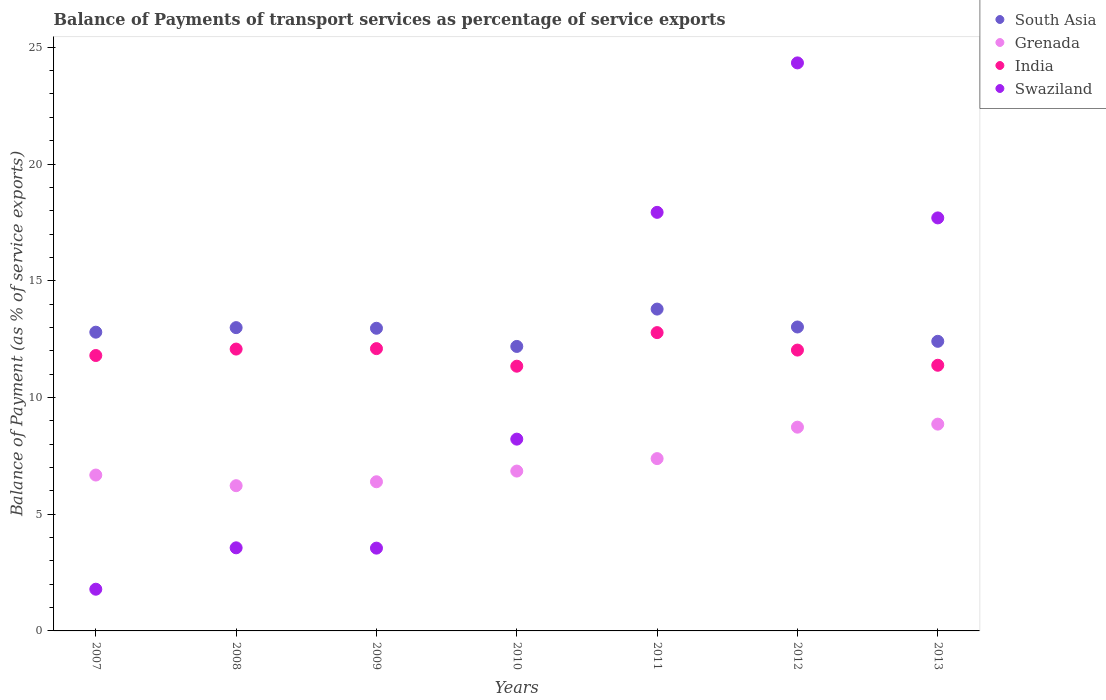What is the balance of payments of transport services in Swaziland in 2010?
Offer a very short reply. 8.22. Across all years, what is the maximum balance of payments of transport services in India?
Offer a terse response. 12.78. Across all years, what is the minimum balance of payments of transport services in India?
Offer a very short reply. 11.34. In which year was the balance of payments of transport services in India maximum?
Your answer should be compact. 2011. In which year was the balance of payments of transport services in India minimum?
Ensure brevity in your answer.  2010. What is the total balance of payments of transport services in South Asia in the graph?
Keep it short and to the point. 90.15. What is the difference between the balance of payments of transport services in India in 2007 and that in 2013?
Give a very brief answer. 0.42. What is the difference between the balance of payments of transport services in South Asia in 2009 and the balance of payments of transport services in Swaziland in 2010?
Provide a succinct answer. 4.75. What is the average balance of payments of transport services in Swaziland per year?
Keep it short and to the point. 11.01. In the year 2010, what is the difference between the balance of payments of transport services in Grenada and balance of payments of transport services in India?
Your response must be concise. -4.49. In how many years, is the balance of payments of transport services in Swaziland greater than 15 %?
Make the answer very short. 3. What is the ratio of the balance of payments of transport services in Grenada in 2008 to that in 2013?
Your answer should be very brief. 0.7. Is the balance of payments of transport services in Swaziland in 2009 less than that in 2010?
Provide a succinct answer. Yes. Is the difference between the balance of payments of transport services in Grenada in 2011 and 2013 greater than the difference between the balance of payments of transport services in India in 2011 and 2013?
Your response must be concise. No. What is the difference between the highest and the second highest balance of payments of transport services in Swaziland?
Offer a terse response. 6.4. What is the difference between the highest and the lowest balance of payments of transport services in India?
Offer a terse response. 1.44. In how many years, is the balance of payments of transport services in India greater than the average balance of payments of transport services in India taken over all years?
Offer a terse response. 4. Is the sum of the balance of payments of transport services in Swaziland in 2009 and 2010 greater than the maximum balance of payments of transport services in India across all years?
Your response must be concise. No. Is it the case that in every year, the sum of the balance of payments of transport services in Grenada and balance of payments of transport services in South Asia  is greater than the balance of payments of transport services in Swaziland?
Offer a terse response. No. Does the balance of payments of transport services in Grenada monotonically increase over the years?
Offer a terse response. No. Is the balance of payments of transport services in Swaziland strictly greater than the balance of payments of transport services in Grenada over the years?
Offer a terse response. No. Is the balance of payments of transport services in Swaziland strictly less than the balance of payments of transport services in Grenada over the years?
Ensure brevity in your answer.  No. How many dotlines are there?
Ensure brevity in your answer.  4. Are the values on the major ticks of Y-axis written in scientific E-notation?
Keep it short and to the point. No. Does the graph contain grids?
Keep it short and to the point. No. What is the title of the graph?
Provide a succinct answer. Balance of Payments of transport services as percentage of service exports. Does "Euro area" appear as one of the legend labels in the graph?
Offer a very short reply. No. What is the label or title of the Y-axis?
Provide a succinct answer. Balance of Payment (as % of service exports). What is the Balance of Payment (as % of service exports) of South Asia in 2007?
Provide a short and direct response. 12.8. What is the Balance of Payment (as % of service exports) in Grenada in 2007?
Keep it short and to the point. 6.68. What is the Balance of Payment (as % of service exports) of India in 2007?
Offer a very short reply. 11.8. What is the Balance of Payment (as % of service exports) of Swaziland in 2007?
Your response must be concise. 1.79. What is the Balance of Payment (as % of service exports) of South Asia in 2008?
Make the answer very short. 12.99. What is the Balance of Payment (as % of service exports) in Grenada in 2008?
Your answer should be compact. 6.22. What is the Balance of Payment (as % of service exports) of India in 2008?
Your answer should be very brief. 12.07. What is the Balance of Payment (as % of service exports) in Swaziland in 2008?
Your response must be concise. 3.56. What is the Balance of Payment (as % of service exports) in South Asia in 2009?
Offer a terse response. 12.96. What is the Balance of Payment (as % of service exports) in Grenada in 2009?
Your response must be concise. 6.39. What is the Balance of Payment (as % of service exports) in India in 2009?
Make the answer very short. 12.09. What is the Balance of Payment (as % of service exports) of Swaziland in 2009?
Your response must be concise. 3.55. What is the Balance of Payment (as % of service exports) in South Asia in 2010?
Make the answer very short. 12.19. What is the Balance of Payment (as % of service exports) in Grenada in 2010?
Your response must be concise. 6.85. What is the Balance of Payment (as % of service exports) in India in 2010?
Keep it short and to the point. 11.34. What is the Balance of Payment (as % of service exports) of Swaziland in 2010?
Provide a succinct answer. 8.22. What is the Balance of Payment (as % of service exports) of South Asia in 2011?
Keep it short and to the point. 13.79. What is the Balance of Payment (as % of service exports) of Grenada in 2011?
Give a very brief answer. 7.38. What is the Balance of Payment (as % of service exports) of India in 2011?
Provide a short and direct response. 12.78. What is the Balance of Payment (as % of service exports) of Swaziland in 2011?
Give a very brief answer. 17.93. What is the Balance of Payment (as % of service exports) of South Asia in 2012?
Keep it short and to the point. 13.02. What is the Balance of Payment (as % of service exports) in Grenada in 2012?
Make the answer very short. 8.73. What is the Balance of Payment (as % of service exports) of India in 2012?
Keep it short and to the point. 12.03. What is the Balance of Payment (as % of service exports) of Swaziland in 2012?
Keep it short and to the point. 24.33. What is the Balance of Payment (as % of service exports) in South Asia in 2013?
Offer a terse response. 12.41. What is the Balance of Payment (as % of service exports) of Grenada in 2013?
Provide a succinct answer. 8.86. What is the Balance of Payment (as % of service exports) in India in 2013?
Make the answer very short. 11.38. What is the Balance of Payment (as % of service exports) of Swaziland in 2013?
Make the answer very short. 17.69. Across all years, what is the maximum Balance of Payment (as % of service exports) in South Asia?
Provide a succinct answer. 13.79. Across all years, what is the maximum Balance of Payment (as % of service exports) of Grenada?
Your response must be concise. 8.86. Across all years, what is the maximum Balance of Payment (as % of service exports) of India?
Your answer should be very brief. 12.78. Across all years, what is the maximum Balance of Payment (as % of service exports) in Swaziland?
Ensure brevity in your answer.  24.33. Across all years, what is the minimum Balance of Payment (as % of service exports) in South Asia?
Give a very brief answer. 12.19. Across all years, what is the minimum Balance of Payment (as % of service exports) in Grenada?
Your response must be concise. 6.22. Across all years, what is the minimum Balance of Payment (as % of service exports) in India?
Keep it short and to the point. 11.34. Across all years, what is the minimum Balance of Payment (as % of service exports) in Swaziland?
Your answer should be compact. 1.79. What is the total Balance of Payment (as % of service exports) in South Asia in the graph?
Make the answer very short. 90.15. What is the total Balance of Payment (as % of service exports) in Grenada in the graph?
Your answer should be compact. 51.1. What is the total Balance of Payment (as % of service exports) in India in the graph?
Make the answer very short. 83.49. What is the total Balance of Payment (as % of service exports) in Swaziland in the graph?
Keep it short and to the point. 77.06. What is the difference between the Balance of Payment (as % of service exports) of South Asia in 2007 and that in 2008?
Offer a very short reply. -0.19. What is the difference between the Balance of Payment (as % of service exports) of Grenada in 2007 and that in 2008?
Your response must be concise. 0.46. What is the difference between the Balance of Payment (as % of service exports) of India in 2007 and that in 2008?
Ensure brevity in your answer.  -0.28. What is the difference between the Balance of Payment (as % of service exports) of Swaziland in 2007 and that in 2008?
Your answer should be compact. -1.77. What is the difference between the Balance of Payment (as % of service exports) in South Asia in 2007 and that in 2009?
Offer a terse response. -0.17. What is the difference between the Balance of Payment (as % of service exports) of Grenada in 2007 and that in 2009?
Provide a succinct answer. 0.29. What is the difference between the Balance of Payment (as % of service exports) in India in 2007 and that in 2009?
Keep it short and to the point. -0.3. What is the difference between the Balance of Payment (as % of service exports) of Swaziland in 2007 and that in 2009?
Your response must be concise. -1.76. What is the difference between the Balance of Payment (as % of service exports) of South Asia in 2007 and that in 2010?
Give a very brief answer. 0.61. What is the difference between the Balance of Payment (as % of service exports) in Grenada in 2007 and that in 2010?
Provide a short and direct response. -0.17. What is the difference between the Balance of Payment (as % of service exports) in India in 2007 and that in 2010?
Ensure brevity in your answer.  0.46. What is the difference between the Balance of Payment (as % of service exports) in Swaziland in 2007 and that in 2010?
Give a very brief answer. -6.43. What is the difference between the Balance of Payment (as % of service exports) in South Asia in 2007 and that in 2011?
Offer a very short reply. -0.99. What is the difference between the Balance of Payment (as % of service exports) of Grenada in 2007 and that in 2011?
Give a very brief answer. -0.7. What is the difference between the Balance of Payment (as % of service exports) of India in 2007 and that in 2011?
Offer a terse response. -0.98. What is the difference between the Balance of Payment (as % of service exports) of Swaziland in 2007 and that in 2011?
Keep it short and to the point. -16.14. What is the difference between the Balance of Payment (as % of service exports) of South Asia in 2007 and that in 2012?
Offer a very short reply. -0.22. What is the difference between the Balance of Payment (as % of service exports) in Grenada in 2007 and that in 2012?
Your answer should be very brief. -2.05. What is the difference between the Balance of Payment (as % of service exports) in India in 2007 and that in 2012?
Provide a succinct answer. -0.23. What is the difference between the Balance of Payment (as % of service exports) in Swaziland in 2007 and that in 2012?
Keep it short and to the point. -22.55. What is the difference between the Balance of Payment (as % of service exports) in South Asia in 2007 and that in 2013?
Provide a succinct answer. 0.39. What is the difference between the Balance of Payment (as % of service exports) of Grenada in 2007 and that in 2013?
Provide a short and direct response. -2.18. What is the difference between the Balance of Payment (as % of service exports) of India in 2007 and that in 2013?
Offer a terse response. 0.42. What is the difference between the Balance of Payment (as % of service exports) of Swaziland in 2007 and that in 2013?
Give a very brief answer. -15.91. What is the difference between the Balance of Payment (as % of service exports) in South Asia in 2008 and that in 2009?
Keep it short and to the point. 0.03. What is the difference between the Balance of Payment (as % of service exports) of Grenada in 2008 and that in 2009?
Provide a short and direct response. -0.17. What is the difference between the Balance of Payment (as % of service exports) of India in 2008 and that in 2009?
Your answer should be compact. -0.02. What is the difference between the Balance of Payment (as % of service exports) in Swaziland in 2008 and that in 2009?
Your response must be concise. 0.01. What is the difference between the Balance of Payment (as % of service exports) in South Asia in 2008 and that in 2010?
Keep it short and to the point. 0.81. What is the difference between the Balance of Payment (as % of service exports) of Grenada in 2008 and that in 2010?
Your answer should be compact. -0.63. What is the difference between the Balance of Payment (as % of service exports) in India in 2008 and that in 2010?
Provide a short and direct response. 0.73. What is the difference between the Balance of Payment (as % of service exports) in Swaziland in 2008 and that in 2010?
Make the answer very short. -4.66. What is the difference between the Balance of Payment (as % of service exports) of South Asia in 2008 and that in 2011?
Offer a very short reply. -0.79. What is the difference between the Balance of Payment (as % of service exports) in Grenada in 2008 and that in 2011?
Your answer should be very brief. -1.16. What is the difference between the Balance of Payment (as % of service exports) in India in 2008 and that in 2011?
Keep it short and to the point. -0.7. What is the difference between the Balance of Payment (as % of service exports) in Swaziland in 2008 and that in 2011?
Your answer should be very brief. -14.37. What is the difference between the Balance of Payment (as % of service exports) of South Asia in 2008 and that in 2012?
Ensure brevity in your answer.  -0.03. What is the difference between the Balance of Payment (as % of service exports) of Grenada in 2008 and that in 2012?
Offer a very short reply. -2.51. What is the difference between the Balance of Payment (as % of service exports) in India in 2008 and that in 2012?
Offer a terse response. 0.04. What is the difference between the Balance of Payment (as % of service exports) of Swaziland in 2008 and that in 2012?
Give a very brief answer. -20.77. What is the difference between the Balance of Payment (as % of service exports) in South Asia in 2008 and that in 2013?
Give a very brief answer. 0.59. What is the difference between the Balance of Payment (as % of service exports) of Grenada in 2008 and that in 2013?
Ensure brevity in your answer.  -2.64. What is the difference between the Balance of Payment (as % of service exports) of India in 2008 and that in 2013?
Your answer should be very brief. 0.69. What is the difference between the Balance of Payment (as % of service exports) in Swaziland in 2008 and that in 2013?
Keep it short and to the point. -14.13. What is the difference between the Balance of Payment (as % of service exports) of South Asia in 2009 and that in 2010?
Your response must be concise. 0.78. What is the difference between the Balance of Payment (as % of service exports) of Grenada in 2009 and that in 2010?
Make the answer very short. -0.46. What is the difference between the Balance of Payment (as % of service exports) of India in 2009 and that in 2010?
Your answer should be compact. 0.75. What is the difference between the Balance of Payment (as % of service exports) of Swaziland in 2009 and that in 2010?
Offer a very short reply. -4.67. What is the difference between the Balance of Payment (as % of service exports) in South Asia in 2009 and that in 2011?
Offer a terse response. -0.82. What is the difference between the Balance of Payment (as % of service exports) of Grenada in 2009 and that in 2011?
Provide a succinct answer. -0.99. What is the difference between the Balance of Payment (as % of service exports) of India in 2009 and that in 2011?
Offer a very short reply. -0.69. What is the difference between the Balance of Payment (as % of service exports) in Swaziland in 2009 and that in 2011?
Your answer should be very brief. -14.38. What is the difference between the Balance of Payment (as % of service exports) of South Asia in 2009 and that in 2012?
Offer a terse response. -0.05. What is the difference between the Balance of Payment (as % of service exports) of Grenada in 2009 and that in 2012?
Give a very brief answer. -2.34. What is the difference between the Balance of Payment (as % of service exports) in India in 2009 and that in 2012?
Ensure brevity in your answer.  0.06. What is the difference between the Balance of Payment (as % of service exports) in Swaziland in 2009 and that in 2012?
Provide a succinct answer. -20.79. What is the difference between the Balance of Payment (as % of service exports) of South Asia in 2009 and that in 2013?
Give a very brief answer. 0.56. What is the difference between the Balance of Payment (as % of service exports) of Grenada in 2009 and that in 2013?
Provide a succinct answer. -2.47. What is the difference between the Balance of Payment (as % of service exports) of India in 2009 and that in 2013?
Provide a succinct answer. 0.71. What is the difference between the Balance of Payment (as % of service exports) in Swaziland in 2009 and that in 2013?
Your response must be concise. -14.15. What is the difference between the Balance of Payment (as % of service exports) in South Asia in 2010 and that in 2011?
Offer a very short reply. -1.6. What is the difference between the Balance of Payment (as % of service exports) in Grenada in 2010 and that in 2011?
Offer a terse response. -0.53. What is the difference between the Balance of Payment (as % of service exports) of India in 2010 and that in 2011?
Ensure brevity in your answer.  -1.44. What is the difference between the Balance of Payment (as % of service exports) of Swaziland in 2010 and that in 2011?
Provide a short and direct response. -9.71. What is the difference between the Balance of Payment (as % of service exports) in South Asia in 2010 and that in 2012?
Your answer should be compact. -0.83. What is the difference between the Balance of Payment (as % of service exports) of Grenada in 2010 and that in 2012?
Ensure brevity in your answer.  -1.88. What is the difference between the Balance of Payment (as % of service exports) of India in 2010 and that in 2012?
Provide a short and direct response. -0.69. What is the difference between the Balance of Payment (as % of service exports) of Swaziland in 2010 and that in 2012?
Make the answer very short. -16.12. What is the difference between the Balance of Payment (as % of service exports) in South Asia in 2010 and that in 2013?
Your answer should be compact. -0.22. What is the difference between the Balance of Payment (as % of service exports) in Grenada in 2010 and that in 2013?
Keep it short and to the point. -2.01. What is the difference between the Balance of Payment (as % of service exports) of India in 2010 and that in 2013?
Provide a short and direct response. -0.04. What is the difference between the Balance of Payment (as % of service exports) in Swaziland in 2010 and that in 2013?
Your answer should be compact. -9.48. What is the difference between the Balance of Payment (as % of service exports) of South Asia in 2011 and that in 2012?
Ensure brevity in your answer.  0.77. What is the difference between the Balance of Payment (as % of service exports) in Grenada in 2011 and that in 2012?
Offer a very short reply. -1.35. What is the difference between the Balance of Payment (as % of service exports) in India in 2011 and that in 2012?
Make the answer very short. 0.75. What is the difference between the Balance of Payment (as % of service exports) of Swaziland in 2011 and that in 2012?
Your answer should be very brief. -6.4. What is the difference between the Balance of Payment (as % of service exports) in South Asia in 2011 and that in 2013?
Offer a terse response. 1.38. What is the difference between the Balance of Payment (as % of service exports) of Grenada in 2011 and that in 2013?
Offer a terse response. -1.48. What is the difference between the Balance of Payment (as % of service exports) of India in 2011 and that in 2013?
Your response must be concise. 1.4. What is the difference between the Balance of Payment (as % of service exports) of Swaziland in 2011 and that in 2013?
Keep it short and to the point. 0.24. What is the difference between the Balance of Payment (as % of service exports) in South Asia in 2012 and that in 2013?
Give a very brief answer. 0.61. What is the difference between the Balance of Payment (as % of service exports) in Grenada in 2012 and that in 2013?
Your response must be concise. -0.13. What is the difference between the Balance of Payment (as % of service exports) of India in 2012 and that in 2013?
Ensure brevity in your answer.  0.65. What is the difference between the Balance of Payment (as % of service exports) of Swaziland in 2012 and that in 2013?
Make the answer very short. 6.64. What is the difference between the Balance of Payment (as % of service exports) in South Asia in 2007 and the Balance of Payment (as % of service exports) in Grenada in 2008?
Provide a short and direct response. 6.58. What is the difference between the Balance of Payment (as % of service exports) in South Asia in 2007 and the Balance of Payment (as % of service exports) in India in 2008?
Keep it short and to the point. 0.72. What is the difference between the Balance of Payment (as % of service exports) in South Asia in 2007 and the Balance of Payment (as % of service exports) in Swaziland in 2008?
Make the answer very short. 9.24. What is the difference between the Balance of Payment (as % of service exports) in Grenada in 2007 and the Balance of Payment (as % of service exports) in India in 2008?
Keep it short and to the point. -5.4. What is the difference between the Balance of Payment (as % of service exports) of Grenada in 2007 and the Balance of Payment (as % of service exports) of Swaziland in 2008?
Offer a very short reply. 3.12. What is the difference between the Balance of Payment (as % of service exports) of India in 2007 and the Balance of Payment (as % of service exports) of Swaziland in 2008?
Your answer should be compact. 8.24. What is the difference between the Balance of Payment (as % of service exports) of South Asia in 2007 and the Balance of Payment (as % of service exports) of Grenada in 2009?
Provide a succinct answer. 6.41. What is the difference between the Balance of Payment (as % of service exports) of South Asia in 2007 and the Balance of Payment (as % of service exports) of India in 2009?
Offer a terse response. 0.7. What is the difference between the Balance of Payment (as % of service exports) in South Asia in 2007 and the Balance of Payment (as % of service exports) in Swaziland in 2009?
Provide a succinct answer. 9.25. What is the difference between the Balance of Payment (as % of service exports) of Grenada in 2007 and the Balance of Payment (as % of service exports) of India in 2009?
Offer a very short reply. -5.42. What is the difference between the Balance of Payment (as % of service exports) in Grenada in 2007 and the Balance of Payment (as % of service exports) in Swaziland in 2009?
Offer a very short reply. 3.13. What is the difference between the Balance of Payment (as % of service exports) in India in 2007 and the Balance of Payment (as % of service exports) in Swaziland in 2009?
Provide a succinct answer. 8.25. What is the difference between the Balance of Payment (as % of service exports) in South Asia in 2007 and the Balance of Payment (as % of service exports) in Grenada in 2010?
Provide a short and direct response. 5.95. What is the difference between the Balance of Payment (as % of service exports) in South Asia in 2007 and the Balance of Payment (as % of service exports) in India in 2010?
Keep it short and to the point. 1.46. What is the difference between the Balance of Payment (as % of service exports) of South Asia in 2007 and the Balance of Payment (as % of service exports) of Swaziland in 2010?
Make the answer very short. 4.58. What is the difference between the Balance of Payment (as % of service exports) of Grenada in 2007 and the Balance of Payment (as % of service exports) of India in 2010?
Offer a very short reply. -4.66. What is the difference between the Balance of Payment (as % of service exports) in Grenada in 2007 and the Balance of Payment (as % of service exports) in Swaziland in 2010?
Provide a succinct answer. -1.54. What is the difference between the Balance of Payment (as % of service exports) of India in 2007 and the Balance of Payment (as % of service exports) of Swaziland in 2010?
Your answer should be compact. 3.58. What is the difference between the Balance of Payment (as % of service exports) in South Asia in 2007 and the Balance of Payment (as % of service exports) in Grenada in 2011?
Make the answer very short. 5.42. What is the difference between the Balance of Payment (as % of service exports) in South Asia in 2007 and the Balance of Payment (as % of service exports) in India in 2011?
Offer a terse response. 0.02. What is the difference between the Balance of Payment (as % of service exports) in South Asia in 2007 and the Balance of Payment (as % of service exports) in Swaziland in 2011?
Your answer should be very brief. -5.13. What is the difference between the Balance of Payment (as % of service exports) in Grenada in 2007 and the Balance of Payment (as % of service exports) in India in 2011?
Offer a terse response. -6.1. What is the difference between the Balance of Payment (as % of service exports) in Grenada in 2007 and the Balance of Payment (as % of service exports) in Swaziland in 2011?
Offer a terse response. -11.25. What is the difference between the Balance of Payment (as % of service exports) in India in 2007 and the Balance of Payment (as % of service exports) in Swaziland in 2011?
Your answer should be very brief. -6.13. What is the difference between the Balance of Payment (as % of service exports) in South Asia in 2007 and the Balance of Payment (as % of service exports) in Grenada in 2012?
Provide a short and direct response. 4.07. What is the difference between the Balance of Payment (as % of service exports) of South Asia in 2007 and the Balance of Payment (as % of service exports) of India in 2012?
Offer a terse response. 0.77. What is the difference between the Balance of Payment (as % of service exports) of South Asia in 2007 and the Balance of Payment (as % of service exports) of Swaziland in 2012?
Make the answer very short. -11.54. What is the difference between the Balance of Payment (as % of service exports) in Grenada in 2007 and the Balance of Payment (as % of service exports) in India in 2012?
Provide a succinct answer. -5.35. What is the difference between the Balance of Payment (as % of service exports) of Grenada in 2007 and the Balance of Payment (as % of service exports) of Swaziland in 2012?
Your response must be concise. -17.65. What is the difference between the Balance of Payment (as % of service exports) of India in 2007 and the Balance of Payment (as % of service exports) of Swaziland in 2012?
Give a very brief answer. -12.53. What is the difference between the Balance of Payment (as % of service exports) of South Asia in 2007 and the Balance of Payment (as % of service exports) of Grenada in 2013?
Your answer should be compact. 3.94. What is the difference between the Balance of Payment (as % of service exports) of South Asia in 2007 and the Balance of Payment (as % of service exports) of India in 2013?
Offer a terse response. 1.42. What is the difference between the Balance of Payment (as % of service exports) of South Asia in 2007 and the Balance of Payment (as % of service exports) of Swaziland in 2013?
Make the answer very short. -4.89. What is the difference between the Balance of Payment (as % of service exports) of Grenada in 2007 and the Balance of Payment (as % of service exports) of India in 2013?
Offer a terse response. -4.7. What is the difference between the Balance of Payment (as % of service exports) of Grenada in 2007 and the Balance of Payment (as % of service exports) of Swaziland in 2013?
Keep it short and to the point. -11.01. What is the difference between the Balance of Payment (as % of service exports) of India in 2007 and the Balance of Payment (as % of service exports) of Swaziland in 2013?
Offer a very short reply. -5.89. What is the difference between the Balance of Payment (as % of service exports) in South Asia in 2008 and the Balance of Payment (as % of service exports) in Grenada in 2009?
Make the answer very short. 6.6. What is the difference between the Balance of Payment (as % of service exports) in South Asia in 2008 and the Balance of Payment (as % of service exports) in India in 2009?
Your answer should be compact. 0.9. What is the difference between the Balance of Payment (as % of service exports) of South Asia in 2008 and the Balance of Payment (as % of service exports) of Swaziland in 2009?
Make the answer very short. 9.45. What is the difference between the Balance of Payment (as % of service exports) in Grenada in 2008 and the Balance of Payment (as % of service exports) in India in 2009?
Give a very brief answer. -5.87. What is the difference between the Balance of Payment (as % of service exports) in Grenada in 2008 and the Balance of Payment (as % of service exports) in Swaziland in 2009?
Offer a terse response. 2.67. What is the difference between the Balance of Payment (as % of service exports) of India in 2008 and the Balance of Payment (as % of service exports) of Swaziland in 2009?
Provide a short and direct response. 8.53. What is the difference between the Balance of Payment (as % of service exports) of South Asia in 2008 and the Balance of Payment (as % of service exports) of Grenada in 2010?
Your answer should be very brief. 6.14. What is the difference between the Balance of Payment (as % of service exports) in South Asia in 2008 and the Balance of Payment (as % of service exports) in India in 2010?
Offer a very short reply. 1.65. What is the difference between the Balance of Payment (as % of service exports) in South Asia in 2008 and the Balance of Payment (as % of service exports) in Swaziland in 2010?
Offer a very short reply. 4.78. What is the difference between the Balance of Payment (as % of service exports) in Grenada in 2008 and the Balance of Payment (as % of service exports) in India in 2010?
Ensure brevity in your answer.  -5.12. What is the difference between the Balance of Payment (as % of service exports) in Grenada in 2008 and the Balance of Payment (as % of service exports) in Swaziland in 2010?
Offer a very short reply. -1.99. What is the difference between the Balance of Payment (as % of service exports) in India in 2008 and the Balance of Payment (as % of service exports) in Swaziland in 2010?
Your answer should be compact. 3.86. What is the difference between the Balance of Payment (as % of service exports) in South Asia in 2008 and the Balance of Payment (as % of service exports) in Grenada in 2011?
Offer a very short reply. 5.61. What is the difference between the Balance of Payment (as % of service exports) of South Asia in 2008 and the Balance of Payment (as % of service exports) of India in 2011?
Give a very brief answer. 0.21. What is the difference between the Balance of Payment (as % of service exports) in South Asia in 2008 and the Balance of Payment (as % of service exports) in Swaziland in 2011?
Your response must be concise. -4.94. What is the difference between the Balance of Payment (as % of service exports) of Grenada in 2008 and the Balance of Payment (as % of service exports) of India in 2011?
Offer a very short reply. -6.56. What is the difference between the Balance of Payment (as % of service exports) of Grenada in 2008 and the Balance of Payment (as % of service exports) of Swaziland in 2011?
Offer a very short reply. -11.71. What is the difference between the Balance of Payment (as % of service exports) of India in 2008 and the Balance of Payment (as % of service exports) of Swaziland in 2011?
Keep it short and to the point. -5.86. What is the difference between the Balance of Payment (as % of service exports) of South Asia in 2008 and the Balance of Payment (as % of service exports) of Grenada in 2012?
Ensure brevity in your answer.  4.26. What is the difference between the Balance of Payment (as % of service exports) in South Asia in 2008 and the Balance of Payment (as % of service exports) in India in 2012?
Your response must be concise. 0.96. What is the difference between the Balance of Payment (as % of service exports) of South Asia in 2008 and the Balance of Payment (as % of service exports) of Swaziland in 2012?
Your answer should be very brief. -11.34. What is the difference between the Balance of Payment (as % of service exports) in Grenada in 2008 and the Balance of Payment (as % of service exports) in India in 2012?
Your response must be concise. -5.81. What is the difference between the Balance of Payment (as % of service exports) in Grenada in 2008 and the Balance of Payment (as % of service exports) in Swaziland in 2012?
Your answer should be very brief. -18.11. What is the difference between the Balance of Payment (as % of service exports) in India in 2008 and the Balance of Payment (as % of service exports) in Swaziland in 2012?
Offer a terse response. -12.26. What is the difference between the Balance of Payment (as % of service exports) in South Asia in 2008 and the Balance of Payment (as % of service exports) in Grenada in 2013?
Offer a very short reply. 4.13. What is the difference between the Balance of Payment (as % of service exports) of South Asia in 2008 and the Balance of Payment (as % of service exports) of India in 2013?
Your answer should be very brief. 1.61. What is the difference between the Balance of Payment (as % of service exports) of South Asia in 2008 and the Balance of Payment (as % of service exports) of Swaziland in 2013?
Provide a succinct answer. -4.7. What is the difference between the Balance of Payment (as % of service exports) in Grenada in 2008 and the Balance of Payment (as % of service exports) in India in 2013?
Make the answer very short. -5.16. What is the difference between the Balance of Payment (as % of service exports) of Grenada in 2008 and the Balance of Payment (as % of service exports) of Swaziland in 2013?
Your answer should be compact. -11.47. What is the difference between the Balance of Payment (as % of service exports) in India in 2008 and the Balance of Payment (as % of service exports) in Swaziland in 2013?
Provide a succinct answer. -5.62. What is the difference between the Balance of Payment (as % of service exports) in South Asia in 2009 and the Balance of Payment (as % of service exports) in Grenada in 2010?
Offer a terse response. 6.12. What is the difference between the Balance of Payment (as % of service exports) of South Asia in 2009 and the Balance of Payment (as % of service exports) of India in 2010?
Give a very brief answer. 1.62. What is the difference between the Balance of Payment (as % of service exports) of South Asia in 2009 and the Balance of Payment (as % of service exports) of Swaziland in 2010?
Provide a succinct answer. 4.75. What is the difference between the Balance of Payment (as % of service exports) in Grenada in 2009 and the Balance of Payment (as % of service exports) in India in 2010?
Provide a short and direct response. -4.95. What is the difference between the Balance of Payment (as % of service exports) of Grenada in 2009 and the Balance of Payment (as % of service exports) of Swaziland in 2010?
Your answer should be compact. -1.83. What is the difference between the Balance of Payment (as % of service exports) in India in 2009 and the Balance of Payment (as % of service exports) in Swaziland in 2010?
Give a very brief answer. 3.88. What is the difference between the Balance of Payment (as % of service exports) of South Asia in 2009 and the Balance of Payment (as % of service exports) of Grenada in 2011?
Keep it short and to the point. 5.58. What is the difference between the Balance of Payment (as % of service exports) of South Asia in 2009 and the Balance of Payment (as % of service exports) of India in 2011?
Offer a terse response. 0.19. What is the difference between the Balance of Payment (as % of service exports) in South Asia in 2009 and the Balance of Payment (as % of service exports) in Swaziland in 2011?
Ensure brevity in your answer.  -4.97. What is the difference between the Balance of Payment (as % of service exports) of Grenada in 2009 and the Balance of Payment (as % of service exports) of India in 2011?
Your response must be concise. -6.39. What is the difference between the Balance of Payment (as % of service exports) in Grenada in 2009 and the Balance of Payment (as % of service exports) in Swaziland in 2011?
Provide a succinct answer. -11.54. What is the difference between the Balance of Payment (as % of service exports) of India in 2009 and the Balance of Payment (as % of service exports) of Swaziland in 2011?
Provide a short and direct response. -5.84. What is the difference between the Balance of Payment (as % of service exports) of South Asia in 2009 and the Balance of Payment (as % of service exports) of Grenada in 2012?
Give a very brief answer. 4.24. What is the difference between the Balance of Payment (as % of service exports) in South Asia in 2009 and the Balance of Payment (as % of service exports) in India in 2012?
Give a very brief answer. 0.93. What is the difference between the Balance of Payment (as % of service exports) in South Asia in 2009 and the Balance of Payment (as % of service exports) in Swaziland in 2012?
Offer a very short reply. -11.37. What is the difference between the Balance of Payment (as % of service exports) in Grenada in 2009 and the Balance of Payment (as % of service exports) in India in 2012?
Your response must be concise. -5.64. What is the difference between the Balance of Payment (as % of service exports) in Grenada in 2009 and the Balance of Payment (as % of service exports) in Swaziland in 2012?
Keep it short and to the point. -17.94. What is the difference between the Balance of Payment (as % of service exports) of India in 2009 and the Balance of Payment (as % of service exports) of Swaziland in 2012?
Provide a short and direct response. -12.24. What is the difference between the Balance of Payment (as % of service exports) of South Asia in 2009 and the Balance of Payment (as % of service exports) of Grenada in 2013?
Ensure brevity in your answer.  4.11. What is the difference between the Balance of Payment (as % of service exports) of South Asia in 2009 and the Balance of Payment (as % of service exports) of India in 2013?
Provide a succinct answer. 1.58. What is the difference between the Balance of Payment (as % of service exports) of South Asia in 2009 and the Balance of Payment (as % of service exports) of Swaziland in 2013?
Give a very brief answer. -4.73. What is the difference between the Balance of Payment (as % of service exports) of Grenada in 2009 and the Balance of Payment (as % of service exports) of India in 2013?
Give a very brief answer. -4.99. What is the difference between the Balance of Payment (as % of service exports) in Grenada in 2009 and the Balance of Payment (as % of service exports) in Swaziland in 2013?
Make the answer very short. -11.3. What is the difference between the Balance of Payment (as % of service exports) in India in 2009 and the Balance of Payment (as % of service exports) in Swaziland in 2013?
Your answer should be very brief. -5.6. What is the difference between the Balance of Payment (as % of service exports) of South Asia in 2010 and the Balance of Payment (as % of service exports) of Grenada in 2011?
Make the answer very short. 4.81. What is the difference between the Balance of Payment (as % of service exports) of South Asia in 2010 and the Balance of Payment (as % of service exports) of India in 2011?
Give a very brief answer. -0.59. What is the difference between the Balance of Payment (as % of service exports) in South Asia in 2010 and the Balance of Payment (as % of service exports) in Swaziland in 2011?
Offer a terse response. -5.74. What is the difference between the Balance of Payment (as % of service exports) of Grenada in 2010 and the Balance of Payment (as % of service exports) of India in 2011?
Your answer should be very brief. -5.93. What is the difference between the Balance of Payment (as % of service exports) in Grenada in 2010 and the Balance of Payment (as % of service exports) in Swaziland in 2011?
Your answer should be compact. -11.08. What is the difference between the Balance of Payment (as % of service exports) of India in 2010 and the Balance of Payment (as % of service exports) of Swaziland in 2011?
Provide a short and direct response. -6.59. What is the difference between the Balance of Payment (as % of service exports) of South Asia in 2010 and the Balance of Payment (as % of service exports) of Grenada in 2012?
Keep it short and to the point. 3.46. What is the difference between the Balance of Payment (as % of service exports) in South Asia in 2010 and the Balance of Payment (as % of service exports) in India in 2012?
Offer a terse response. 0.16. What is the difference between the Balance of Payment (as % of service exports) in South Asia in 2010 and the Balance of Payment (as % of service exports) in Swaziland in 2012?
Offer a terse response. -12.15. What is the difference between the Balance of Payment (as % of service exports) in Grenada in 2010 and the Balance of Payment (as % of service exports) in India in 2012?
Your answer should be compact. -5.18. What is the difference between the Balance of Payment (as % of service exports) in Grenada in 2010 and the Balance of Payment (as % of service exports) in Swaziland in 2012?
Provide a short and direct response. -17.48. What is the difference between the Balance of Payment (as % of service exports) in India in 2010 and the Balance of Payment (as % of service exports) in Swaziland in 2012?
Offer a very short reply. -12.99. What is the difference between the Balance of Payment (as % of service exports) of South Asia in 2010 and the Balance of Payment (as % of service exports) of Grenada in 2013?
Your answer should be very brief. 3.33. What is the difference between the Balance of Payment (as % of service exports) of South Asia in 2010 and the Balance of Payment (as % of service exports) of India in 2013?
Make the answer very short. 0.81. What is the difference between the Balance of Payment (as % of service exports) of South Asia in 2010 and the Balance of Payment (as % of service exports) of Swaziland in 2013?
Make the answer very short. -5.51. What is the difference between the Balance of Payment (as % of service exports) of Grenada in 2010 and the Balance of Payment (as % of service exports) of India in 2013?
Your response must be concise. -4.53. What is the difference between the Balance of Payment (as % of service exports) in Grenada in 2010 and the Balance of Payment (as % of service exports) in Swaziland in 2013?
Your answer should be very brief. -10.84. What is the difference between the Balance of Payment (as % of service exports) of India in 2010 and the Balance of Payment (as % of service exports) of Swaziland in 2013?
Keep it short and to the point. -6.35. What is the difference between the Balance of Payment (as % of service exports) in South Asia in 2011 and the Balance of Payment (as % of service exports) in Grenada in 2012?
Your response must be concise. 5.06. What is the difference between the Balance of Payment (as % of service exports) of South Asia in 2011 and the Balance of Payment (as % of service exports) of India in 2012?
Make the answer very short. 1.76. What is the difference between the Balance of Payment (as % of service exports) in South Asia in 2011 and the Balance of Payment (as % of service exports) in Swaziland in 2012?
Provide a short and direct response. -10.55. What is the difference between the Balance of Payment (as % of service exports) of Grenada in 2011 and the Balance of Payment (as % of service exports) of India in 2012?
Your answer should be compact. -4.65. What is the difference between the Balance of Payment (as % of service exports) in Grenada in 2011 and the Balance of Payment (as % of service exports) in Swaziland in 2012?
Your answer should be compact. -16.95. What is the difference between the Balance of Payment (as % of service exports) in India in 2011 and the Balance of Payment (as % of service exports) in Swaziland in 2012?
Offer a terse response. -11.55. What is the difference between the Balance of Payment (as % of service exports) in South Asia in 2011 and the Balance of Payment (as % of service exports) in Grenada in 2013?
Your response must be concise. 4.93. What is the difference between the Balance of Payment (as % of service exports) in South Asia in 2011 and the Balance of Payment (as % of service exports) in India in 2013?
Keep it short and to the point. 2.41. What is the difference between the Balance of Payment (as % of service exports) of South Asia in 2011 and the Balance of Payment (as % of service exports) of Swaziland in 2013?
Ensure brevity in your answer.  -3.91. What is the difference between the Balance of Payment (as % of service exports) of Grenada in 2011 and the Balance of Payment (as % of service exports) of India in 2013?
Your response must be concise. -4. What is the difference between the Balance of Payment (as % of service exports) of Grenada in 2011 and the Balance of Payment (as % of service exports) of Swaziland in 2013?
Give a very brief answer. -10.31. What is the difference between the Balance of Payment (as % of service exports) in India in 2011 and the Balance of Payment (as % of service exports) in Swaziland in 2013?
Give a very brief answer. -4.91. What is the difference between the Balance of Payment (as % of service exports) of South Asia in 2012 and the Balance of Payment (as % of service exports) of Grenada in 2013?
Your answer should be very brief. 4.16. What is the difference between the Balance of Payment (as % of service exports) in South Asia in 2012 and the Balance of Payment (as % of service exports) in India in 2013?
Your answer should be compact. 1.64. What is the difference between the Balance of Payment (as % of service exports) in South Asia in 2012 and the Balance of Payment (as % of service exports) in Swaziland in 2013?
Offer a terse response. -4.67. What is the difference between the Balance of Payment (as % of service exports) of Grenada in 2012 and the Balance of Payment (as % of service exports) of India in 2013?
Provide a short and direct response. -2.65. What is the difference between the Balance of Payment (as % of service exports) in Grenada in 2012 and the Balance of Payment (as % of service exports) in Swaziland in 2013?
Provide a succinct answer. -8.96. What is the difference between the Balance of Payment (as % of service exports) in India in 2012 and the Balance of Payment (as % of service exports) in Swaziland in 2013?
Make the answer very short. -5.66. What is the average Balance of Payment (as % of service exports) in South Asia per year?
Provide a short and direct response. 12.88. What is the average Balance of Payment (as % of service exports) of Grenada per year?
Provide a succinct answer. 7.3. What is the average Balance of Payment (as % of service exports) in India per year?
Your answer should be very brief. 11.93. What is the average Balance of Payment (as % of service exports) in Swaziland per year?
Provide a succinct answer. 11.01. In the year 2007, what is the difference between the Balance of Payment (as % of service exports) of South Asia and Balance of Payment (as % of service exports) of Grenada?
Make the answer very short. 6.12. In the year 2007, what is the difference between the Balance of Payment (as % of service exports) of South Asia and Balance of Payment (as % of service exports) of Swaziland?
Provide a succinct answer. 11.01. In the year 2007, what is the difference between the Balance of Payment (as % of service exports) in Grenada and Balance of Payment (as % of service exports) in India?
Make the answer very short. -5.12. In the year 2007, what is the difference between the Balance of Payment (as % of service exports) in Grenada and Balance of Payment (as % of service exports) in Swaziland?
Keep it short and to the point. 4.89. In the year 2007, what is the difference between the Balance of Payment (as % of service exports) in India and Balance of Payment (as % of service exports) in Swaziland?
Make the answer very short. 10.01. In the year 2008, what is the difference between the Balance of Payment (as % of service exports) in South Asia and Balance of Payment (as % of service exports) in Grenada?
Your response must be concise. 6.77. In the year 2008, what is the difference between the Balance of Payment (as % of service exports) in South Asia and Balance of Payment (as % of service exports) in India?
Ensure brevity in your answer.  0.92. In the year 2008, what is the difference between the Balance of Payment (as % of service exports) in South Asia and Balance of Payment (as % of service exports) in Swaziland?
Offer a very short reply. 9.43. In the year 2008, what is the difference between the Balance of Payment (as % of service exports) of Grenada and Balance of Payment (as % of service exports) of India?
Make the answer very short. -5.85. In the year 2008, what is the difference between the Balance of Payment (as % of service exports) in Grenada and Balance of Payment (as % of service exports) in Swaziland?
Offer a very short reply. 2.66. In the year 2008, what is the difference between the Balance of Payment (as % of service exports) of India and Balance of Payment (as % of service exports) of Swaziland?
Your answer should be compact. 8.51. In the year 2009, what is the difference between the Balance of Payment (as % of service exports) in South Asia and Balance of Payment (as % of service exports) in Grenada?
Offer a terse response. 6.57. In the year 2009, what is the difference between the Balance of Payment (as % of service exports) of South Asia and Balance of Payment (as % of service exports) of India?
Give a very brief answer. 0.87. In the year 2009, what is the difference between the Balance of Payment (as % of service exports) in South Asia and Balance of Payment (as % of service exports) in Swaziland?
Your answer should be compact. 9.42. In the year 2009, what is the difference between the Balance of Payment (as % of service exports) in Grenada and Balance of Payment (as % of service exports) in India?
Provide a succinct answer. -5.7. In the year 2009, what is the difference between the Balance of Payment (as % of service exports) of Grenada and Balance of Payment (as % of service exports) of Swaziland?
Offer a very short reply. 2.84. In the year 2009, what is the difference between the Balance of Payment (as % of service exports) of India and Balance of Payment (as % of service exports) of Swaziland?
Your answer should be very brief. 8.55. In the year 2010, what is the difference between the Balance of Payment (as % of service exports) in South Asia and Balance of Payment (as % of service exports) in Grenada?
Offer a terse response. 5.34. In the year 2010, what is the difference between the Balance of Payment (as % of service exports) in South Asia and Balance of Payment (as % of service exports) in India?
Provide a succinct answer. 0.85. In the year 2010, what is the difference between the Balance of Payment (as % of service exports) of South Asia and Balance of Payment (as % of service exports) of Swaziland?
Offer a very short reply. 3.97. In the year 2010, what is the difference between the Balance of Payment (as % of service exports) in Grenada and Balance of Payment (as % of service exports) in India?
Offer a terse response. -4.49. In the year 2010, what is the difference between the Balance of Payment (as % of service exports) in Grenada and Balance of Payment (as % of service exports) in Swaziland?
Make the answer very short. -1.37. In the year 2010, what is the difference between the Balance of Payment (as % of service exports) in India and Balance of Payment (as % of service exports) in Swaziland?
Your answer should be very brief. 3.12. In the year 2011, what is the difference between the Balance of Payment (as % of service exports) of South Asia and Balance of Payment (as % of service exports) of Grenada?
Ensure brevity in your answer.  6.41. In the year 2011, what is the difference between the Balance of Payment (as % of service exports) of South Asia and Balance of Payment (as % of service exports) of India?
Your answer should be compact. 1.01. In the year 2011, what is the difference between the Balance of Payment (as % of service exports) in South Asia and Balance of Payment (as % of service exports) in Swaziland?
Your answer should be compact. -4.14. In the year 2011, what is the difference between the Balance of Payment (as % of service exports) of Grenada and Balance of Payment (as % of service exports) of India?
Offer a very short reply. -5.4. In the year 2011, what is the difference between the Balance of Payment (as % of service exports) of Grenada and Balance of Payment (as % of service exports) of Swaziland?
Make the answer very short. -10.55. In the year 2011, what is the difference between the Balance of Payment (as % of service exports) of India and Balance of Payment (as % of service exports) of Swaziland?
Keep it short and to the point. -5.15. In the year 2012, what is the difference between the Balance of Payment (as % of service exports) in South Asia and Balance of Payment (as % of service exports) in Grenada?
Your answer should be very brief. 4.29. In the year 2012, what is the difference between the Balance of Payment (as % of service exports) in South Asia and Balance of Payment (as % of service exports) in Swaziland?
Provide a short and direct response. -11.31. In the year 2012, what is the difference between the Balance of Payment (as % of service exports) in Grenada and Balance of Payment (as % of service exports) in India?
Ensure brevity in your answer.  -3.3. In the year 2012, what is the difference between the Balance of Payment (as % of service exports) in Grenada and Balance of Payment (as % of service exports) in Swaziland?
Ensure brevity in your answer.  -15.6. In the year 2012, what is the difference between the Balance of Payment (as % of service exports) of India and Balance of Payment (as % of service exports) of Swaziland?
Your response must be concise. -12.3. In the year 2013, what is the difference between the Balance of Payment (as % of service exports) of South Asia and Balance of Payment (as % of service exports) of Grenada?
Your response must be concise. 3.55. In the year 2013, what is the difference between the Balance of Payment (as % of service exports) of South Asia and Balance of Payment (as % of service exports) of India?
Offer a terse response. 1.03. In the year 2013, what is the difference between the Balance of Payment (as % of service exports) in South Asia and Balance of Payment (as % of service exports) in Swaziland?
Provide a succinct answer. -5.29. In the year 2013, what is the difference between the Balance of Payment (as % of service exports) of Grenada and Balance of Payment (as % of service exports) of India?
Ensure brevity in your answer.  -2.52. In the year 2013, what is the difference between the Balance of Payment (as % of service exports) of Grenada and Balance of Payment (as % of service exports) of Swaziland?
Your answer should be compact. -8.83. In the year 2013, what is the difference between the Balance of Payment (as % of service exports) in India and Balance of Payment (as % of service exports) in Swaziland?
Your answer should be very brief. -6.31. What is the ratio of the Balance of Payment (as % of service exports) in South Asia in 2007 to that in 2008?
Your response must be concise. 0.98. What is the ratio of the Balance of Payment (as % of service exports) in Grenada in 2007 to that in 2008?
Keep it short and to the point. 1.07. What is the ratio of the Balance of Payment (as % of service exports) in India in 2007 to that in 2008?
Ensure brevity in your answer.  0.98. What is the ratio of the Balance of Payment (as % of service exports) of Swaziland in 2007 to that in 2008?
Make the answer very short. 0.5. What is the ratio of the Balance of Payment (as % of service exports) in South Asia in 2007 to that in 2009?
Your answer should be very brief. 0.99. What is the ratio of the Balance of Payment (as % of service exports) in Grenada in 2007 to that in 2009?
Offer a very short reply. 1.04. What is the ratio of the Balance of Payment (as % of service exports) in India in 2007 to that in 2009?
Offer a terse response. 0.98. What is the ratio of the Balance of Payment (as % of service exports) in Swaziland in 2007 to that in 2009?
Ensure brevity in your answer.  0.5. What is the ratio of the Balance of Payment (as % of service exports) in South Asia in 2007 to that in 2010?
Ensure brevity in your answer.  1.05. What is the ratio of the Balance of Payment (as % of service exports) in Grenada in 2007 to that in 2010?
Your answer should be compact. 0.98. What is the ratio of the Balance of Payment (as % of service exports) of India in 2007 to that in 2010?
Make the answer very short. 1.04. What is the ratio of the Balance of Payment (as % of service exports) of Swaziland in 2007 to that in 2010?
Your answer should be very brief. 0.22. What is the ratio of the Balance of Payment (as % of service exports) in South Asia in 2007 to that in 2011?
Provide a succinct answer. 0.93. What is the ratio of the Balance of Payment (as % of service exports) of Grenada in 2007 to that in 2011?
Your answer should be compact. 0.9. What is the ratio of the Balance of Payment (as % of service exports) of India in 2007 to that in 2011?
Offer a terse response. 0.92. What is the ratio of the Balance of Payment (as % of service exports) of Swaziland in 2007 to that in 2011?
Make the answer very short. 0.1. What is the ratio of the Balance of Payment (as % of service exports) of South Asia in 2007 to that in 2012?
Make the answer very short. 0.98. What is the ratio of the Balance of Payment (as % of service exports) of Grenada in 2007 to that in 2012?
Make the answer very short. 0.77. What is the ratio of the Balance of Payment (as % of service exports) in India in 2007 to that in 2012?
Provide a succinct answer. 0.98. What is the ratio of the Balance of Payment (as % of service exports) in Swaziland in 2007 to that in 2012?
Your response must be concise. 0.07. What is the ratio of the Balance of Payment (as % of service exports) of South Asia in 2007 to that in 2013?
Your answer should be very brief. 1.03. What is the ratio of the Balance of Payment (as % of service exports) in Grenada in 2007 to that in 2013?
Make the answer very short. 0.75. What is the ratio of the Balance of Payment (as % of service exports) in India in 2007 to that in 2013?
Give a very brief answer. 1.04. What is the ratio of the Balance of Payment (as % of service exports) in Swaziland in 2007 to that in 2013?
Your answer should be compact. 0.1. What is the ratio of the Balance of Payment (as % of service exports) in Grenada in 2008 to that in 2009?
Keep it short and to the point. 0.97. What is the ratio of the Balance of Payment (as % of service exports) of India in 2008 to that in 2009?
Offer a very short reply. 1. What is the ratio of the Balance of Payment (as % of service exports) in South Asia in 2008 to that in 2010?
Your answer should be compact. 1.07. What is the ratio of the Balance of Payment (as % of service exports) of Grenada in 2008 to that in 2010?
Give a very brief answer. 0.91. What is the ratio of the Balance of Payment (as % of service exports) in India in 2008 to that in 2010?
Provide a short and direct response. 1.06. What is the ratio of the Balance of Payment (as % of service exports) in Swaziland in 2008 to that in 2010?
Keep it short and to the point. 0.43. What is the ratio of the Balance of Payment (as % of service exports) in South Asia in 2008 to that in 2011?
Give a very brief answer. 0.94. What is the ratio of the Balance of Payment (as % of service exports) of Grenada in 2008 to that in 2011?
Provide a succinct answer. 0.84. What is the ratio of the Balance of Payment (as % of service exports) in India in 2008 to that in 2011?
Provide a short and direct response. 0.94. What is the ratio of the Balance of Payment (as % of service exports) of Swaziland in 2008 to that in 2011?
Provide a short and direct response. 0.2. What is the ratio of the Balance of Payment (as % of service exports) in Grenada in 2008 to that in 2012?
Your answer should be very brief. 0.71. What is the ratio of the Balance of Payment (as % of service exports) of India in 2008 to that in 2012?
Offer a very short reply. 1. What is the ratio of the Balance of Payment (as % of service exports) in Swaziland in 2008 to that in 2012?
Offer a terse response. 0.15. What is the ratio of the Balance of Payment (as % of service exports) of South Asia in 2008 to that in 2013?
Make the answer very short. 1.05. What is the ratio of the Balance of Payment (as % of service exports) of Grenada in 2008 to that in 2013?
Make the answer very short. 0.7. What is the ratio of the Balance of Payment (as % of service exports) in India in 2008 to that in 2013?
Give a very brief answer. 1.06. What is the ratio of the Balance of Payment (as % of service exports) in Swaziland in 2008 to that in 2013?
Make the answer very short. 0.2. What is the ratio of the Balance of Payment (as % of service exports) in South Asia in 2009 to that in 2010?
Provide a succinct answer. 1.06. What is the ratio of the Balance of Payment (as % of service exports) of Grenada in 2009 to that in 2010?
Your answer should be very brief. 0.93. What is the ratio of the Balance of Payment (as % of service exports) in India in 2009 to that in 2010?
Your answer should be very brief. 1.07. What is the ratio of the Balance of Payment (as % of service exports) of Swaziland in 2009 to that in 2010?
Keep it short and to the point. 0.43. What is the ratio of the Balance of Payment (as % of service exports) of South Asia in 2009 to that in 2011?
Your answer should be compact. 0.94. What is the ratio of the Balance of Payment (as % of service exports) of Grenada in 2009 to that in 2011?
Your answer should be very brief. 0.87. What is the ratio of the Balance of Payment (as % of service exports) of India in 2009 to that in 2011?
Provide a short and direct response. 0.95. What is the ratio of the Balance of Payment (as % of service exports) of Swaziland in 2009 to that in 2011?
Keep it short and to the point. 0.2. What is the ratio of the Balance of Payment (as % of service exports) of Grenada in 2009 to that in 2012?
Your response must be concise. 0.73. What is the ratio of the Balance of Payment (as % of service exports) in Swaziland in 2009 to that in 2012?
Your answer should be compact. 0.15. What is the ratio of the Balance of Payment (as % of service exports) in South Asia in 2009 to that in 2013?
Provide a succinct answer. 1.05. What is the ratio of the Balance of Payment (as % of service exports) of Grenada in 2009 to that in 2013?
Ensure brevity in your answer.  0.72. What is the ratio of the Balance of Payment (as % of service exports) of India in 2009 to that in 2013?
Your answer should be compact. 1.06. What is the ratio of the Balance of Payment (as % of service exports) of Swaziland in 2009 to that in 2013?
Give a very brief answer. 0.2. What is the ratio of the Balance of Payment (as % of service exports) in South Asia in 2010 to that in 2011?
Provide a succinct answer. 0.88. What is the ratio of the Balance of Payment (as % of service exports) in Grenada in 2010 to that in 2011?
Your answer should be very brief. 0.93. What is the ratio of the Balance of Payment (as % of service exports) of India in 2010 to that in 2011?
Provide a short and direct response. 0.89. What is the ratio of the Balance of Payment (as % of service exports) of Swaziland in 2010 to that in 2011?
Offer a very short reply. 0.46. What is the ratio of the Balance of Payment (as % of service exports) in South Asia in 2010 to that in 2012?
Give a very brief answer. 0.94. What is the ratio of the Balance of Payment (as % of service exports) of Grenada in 2010 to that in 2012?
Offer a very short reply. 0.78. What is the ratio of the Balance of Payment (as % of service exports) of India in 2010 to that in 2012?
Your response must be concise. 0.94. What is the ratio of the Balance of Payment (as % of service exports) in Swaziland in 2010 to that in 2012?
Ensure brevity in your answer.  0.34. What is the ratio of the Balance of Payment (as % of service exports) in South Asia in 2010 to that in 2013?
Provide a short and direct response. 0.98. What is the ratio of the Balance of Payment (as % of service exports) of Grenada in 2010 to that in 2013?
Provide a succinct answer. 0.77. What is the ratio of the Balance of Payment (as % of service exports) of Swaziland in 2010 to that in 2013?
Keep it short and to the point. 0.46. What is the ratio of the Balance of Payment (as % of service exports) of South Asia in 2011 to that in 2012?
Ensure brevity in your answer.  1.06. What is the ratio of the Balance of Payment (as % of service exports) of Grenada in 2011 to that in 2012?
Give a very brief answer. 0.85. What is the ratio of the Balance of Payment (as % of service exports) in India in 2011 to that in 2012?
Give a very brief answer. 1.06. What is the ratio of the Balance of Payment (as % of service exports) of Swaziland in 2011 to that in 2012?
Keep it short and to the point. 0.74. What is the ratio of the Balance of Payment (as % of service exports) in South Asia in 2011 to that in 2013?
Offer a terse response. 1.11. What is the ratio of the Balance of Payment (as % of service exports) in India in 2011 to that in 2013?
Keep it short and to the point. 1.12. What is the ratio of the Balance of Payment (as % of service exports) of Swaziland in 2011 to that in 2013?
Provide a short and direct response. 1.01. What is the ratio of the Balance of Payment (as % of service exports) in South Asia in 2012 to that in 2013?
Your response must be concise. 1.05. What is the ratio of the Balance of Payment (as % of service exports) of Grenada in 2012 to that in 2013?
Ensure brevity in your answer.  0.99. What is the ratio of the Balance of Payment (as % of service exports) of India in 2012 to that in 2013?
Your response must be concise. 1.06. What is the ratio of the Balance of Payment (as % of service exports) in Swaziland in 2012 to that in 2013?
Provide a succinct answer. 1.38. What is the difference between the highest and the second highest Balance of Payment (as % of service exports) of South Asia?
Offer a terse response. 0.77. What is the difference between the highest and the second highest Balance of Payment (as % of service exports) in Grenada?
Give a very brief answer. 0.13. What is the difference between the highest and the second highest Balance of Payment (as % of service exports) in India?
Your answer should be very brief. 0.69. What is the difference between the highest and the second highest Balance of Payment (as % of service exports) of Swaziland?
Offer a terse response. 6.4. What is the difference between the highest and the lowest Balance of Payment (as % of service exports) of South Asia?
Provide a succinct answer. 1.6. What is the difference between the highest and the lowest Balance of Payment (as % of service exports) of Grenada?
Provide a succinct answer. 2.64. What is the difference between the highest and the lowest Balance of Payment (as % of service exports) in India?
Ensure brevity in your answer.  1.44. What is the difference between the highest and the lowest Balance of Payment (as % of service exports) of Swaziland?
Provide a short and direct response. 22.55. 